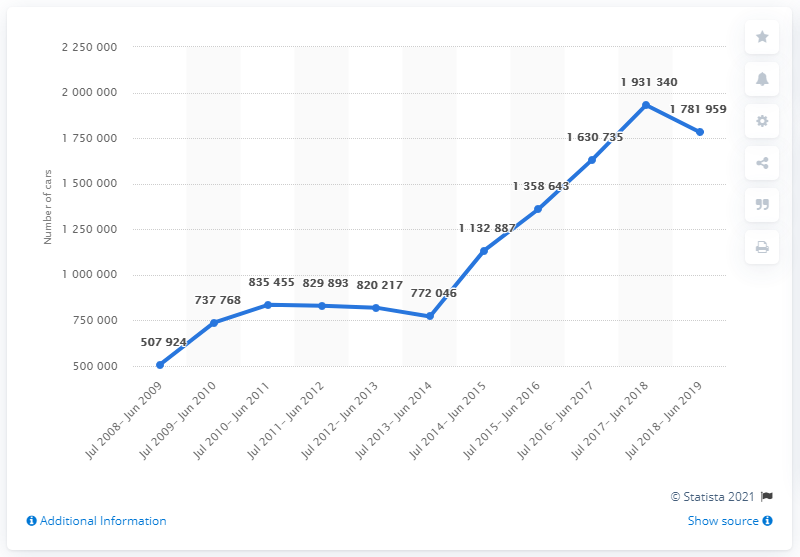Give some essential details in this illustration. The average sales number for the last two years is 18,566,49.5. The sales number reached its peak from July 2017 to June 2018. 